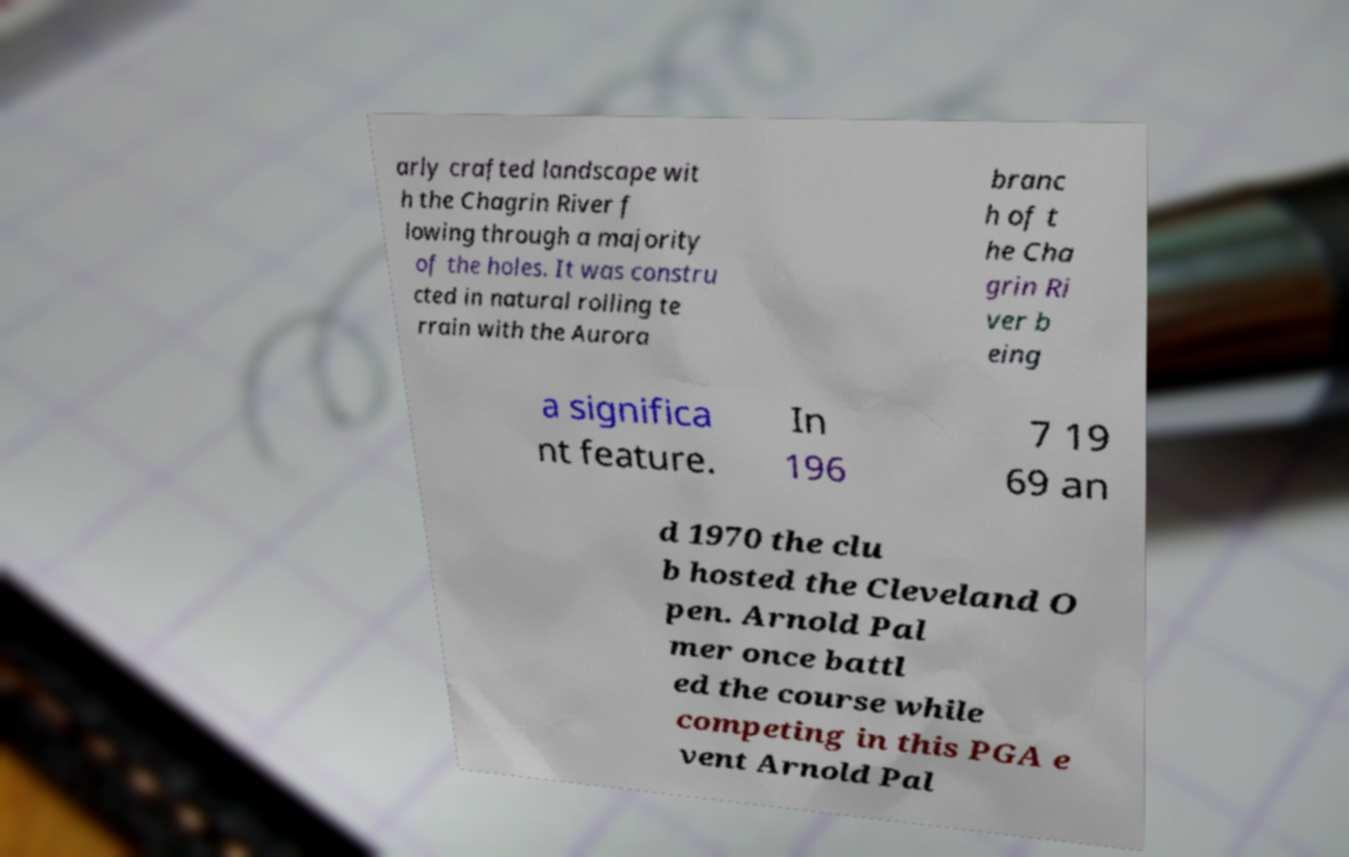Could you extract and type out the text from this image? arly crafted landscape wit h the Chagrin River f lowing through a majority of the holes. It was constru cted in natural rolling te rrain with the Aurora branc h of t he Cha grin Ri ver b eing a significa nt feature. In 196 7 19 69 an d 1970 the clu b hosted the Cleveland O pen. Arnold Pal mer once battl ed the course while competing in this PGA e vent Arnold Pal 